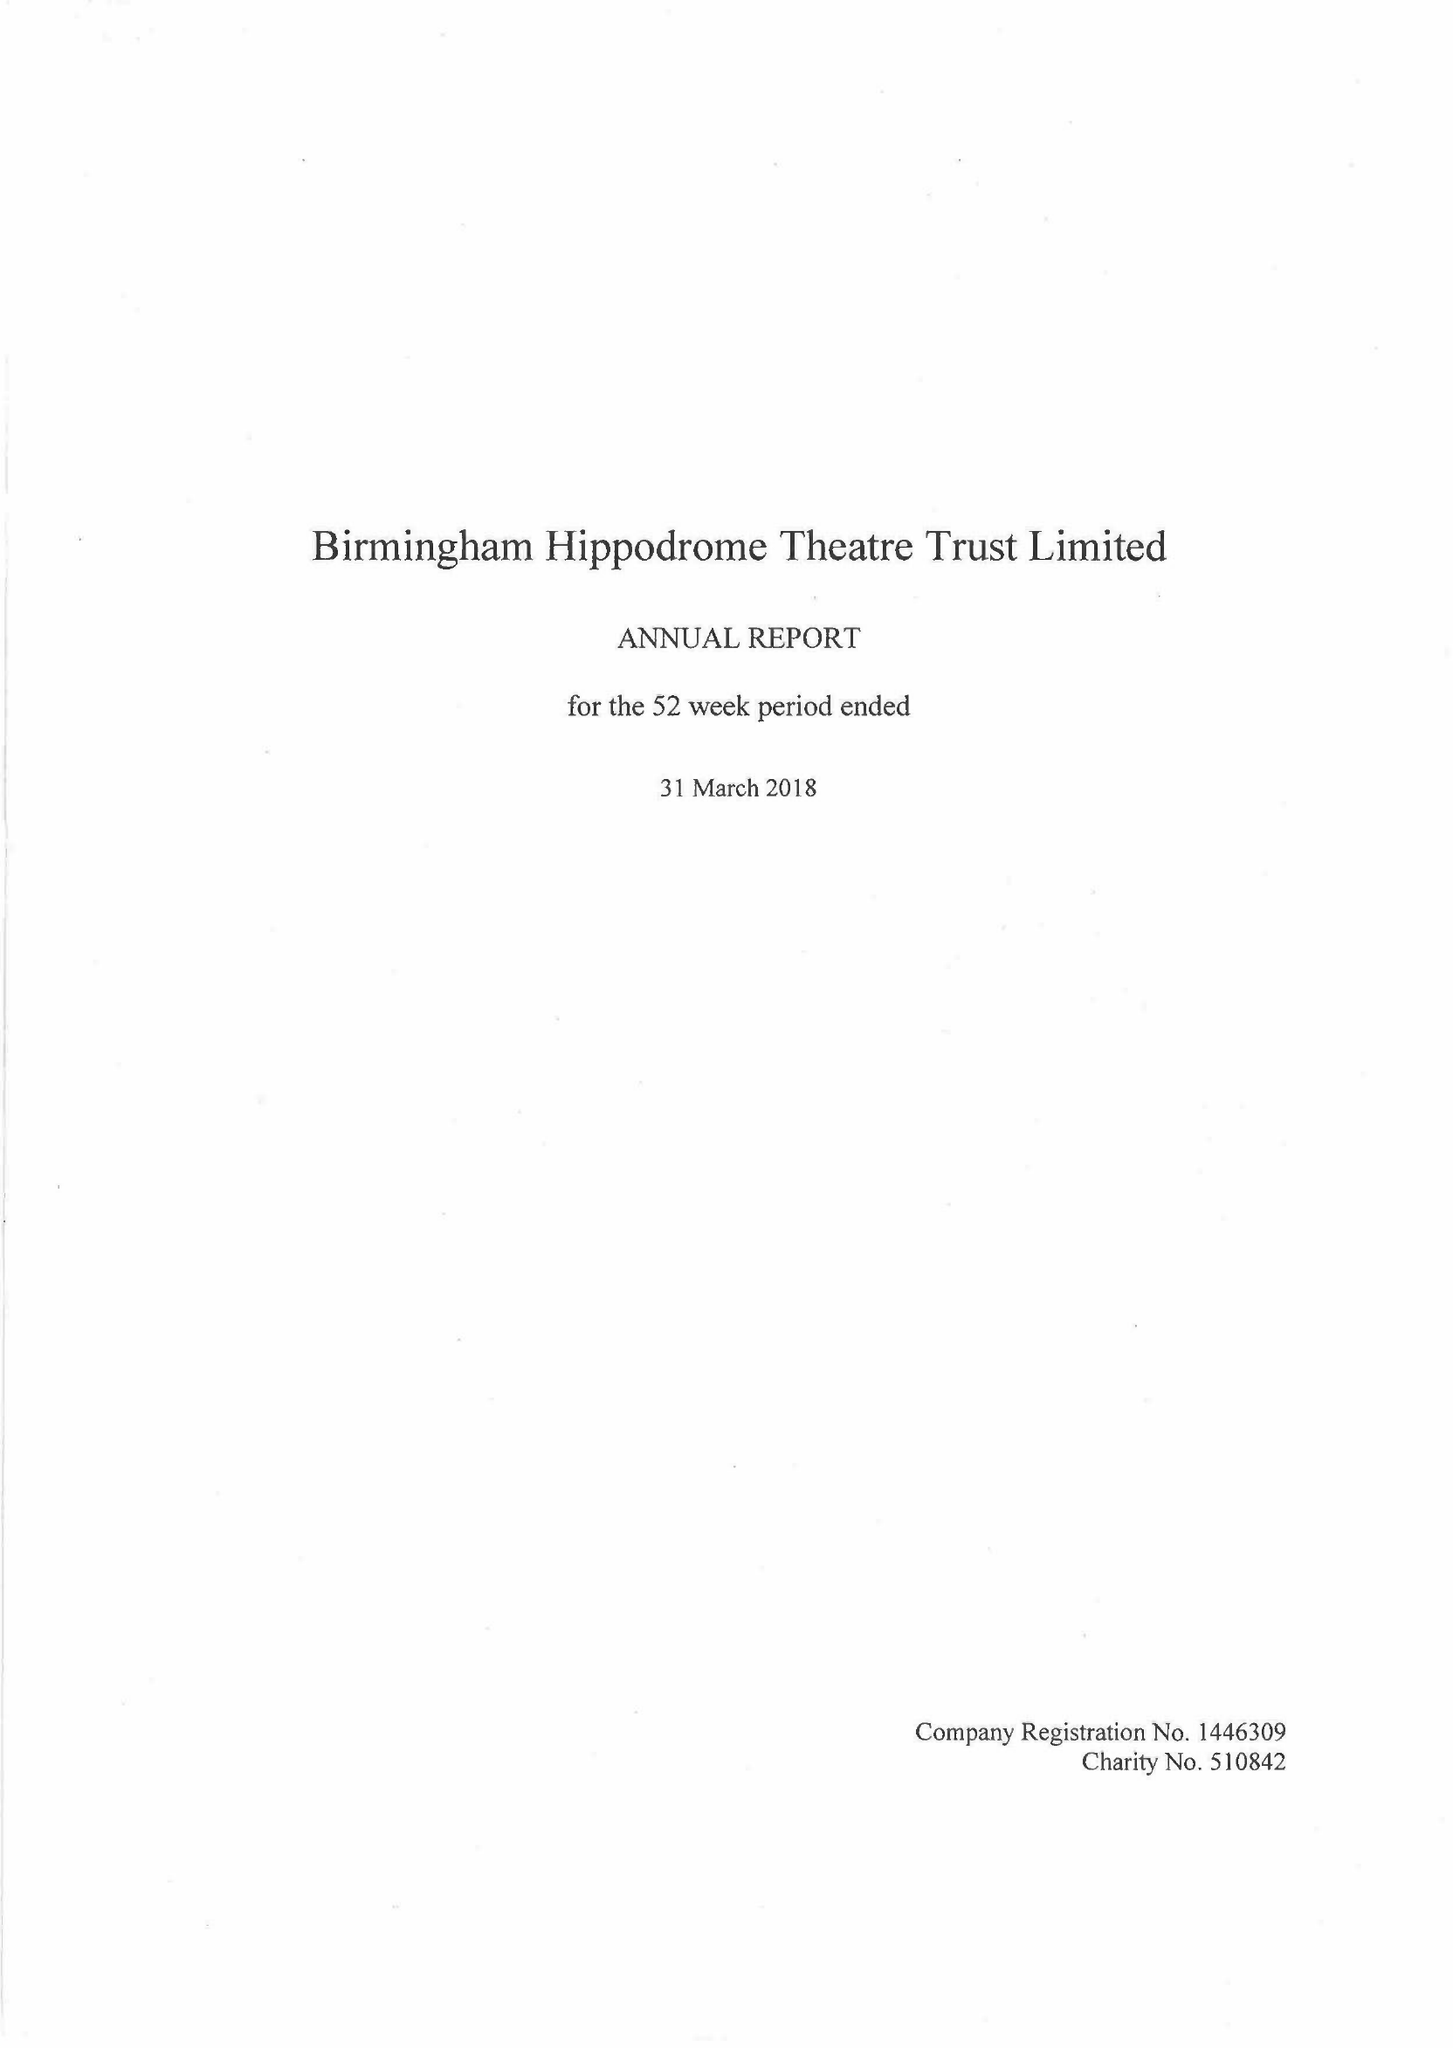What is the value for the charity_name?
Answer the question using a single word or phrase. Birmingham Hippodrome Theatre Trust Ltd. 